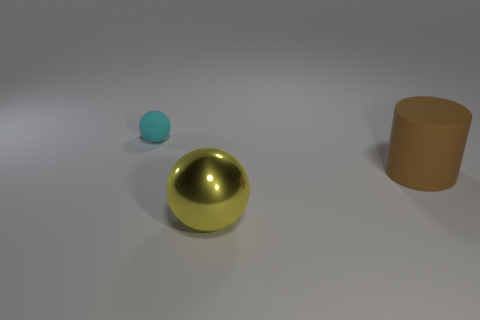There is a ball behind the large shiny ball; is it the same color as the rubber thing on the right side of the tiny thing?
Your answer should be compact. No. Are there any other big objects of the same shape as the brown rubber thing?
Provide a short and direct response. No. What is the color of the matte object right of the ball that is in front of the matte object that is behind the big matte object?
Keep it short and to the point. Brown. Is the number of large yellow shiny spheres in front of the yellow object the same as the number of yellow metal things?
Offer a very short reply. No. There is a sphere that is to the right of the cyan thing; is its size the same as the large matte thing?
Your response must be concise. Yes. What number of small gray shiny cylinders are there?
Ensure brevity in your answer.  0. What number of objects are to the left of the big brown object and behind the big metallic ball?
Ensure brevity in your answer.  1. Are there any other large cyan cylinders made of the same material as the big cylinder?
Offer a terse response. No. The object that is behind the matte thing right of the metal thing is made of what material?
Offer a very short reply. Rubber. Are there the same number of big yellow metallic spheres that are to the left of the tiny cyan object and cyan rubber things that are on the right side of the metallic sphere?
Provide a short and direct response. Yes. 